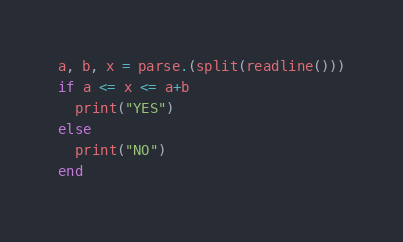<code> <loc_0><loc_0><loc_500><loc_500><_Julia_>a, b, x = parse.(split(readline()))
if a <= x <= a+b
  print("YES")
else
  print("NO")
end</code> 